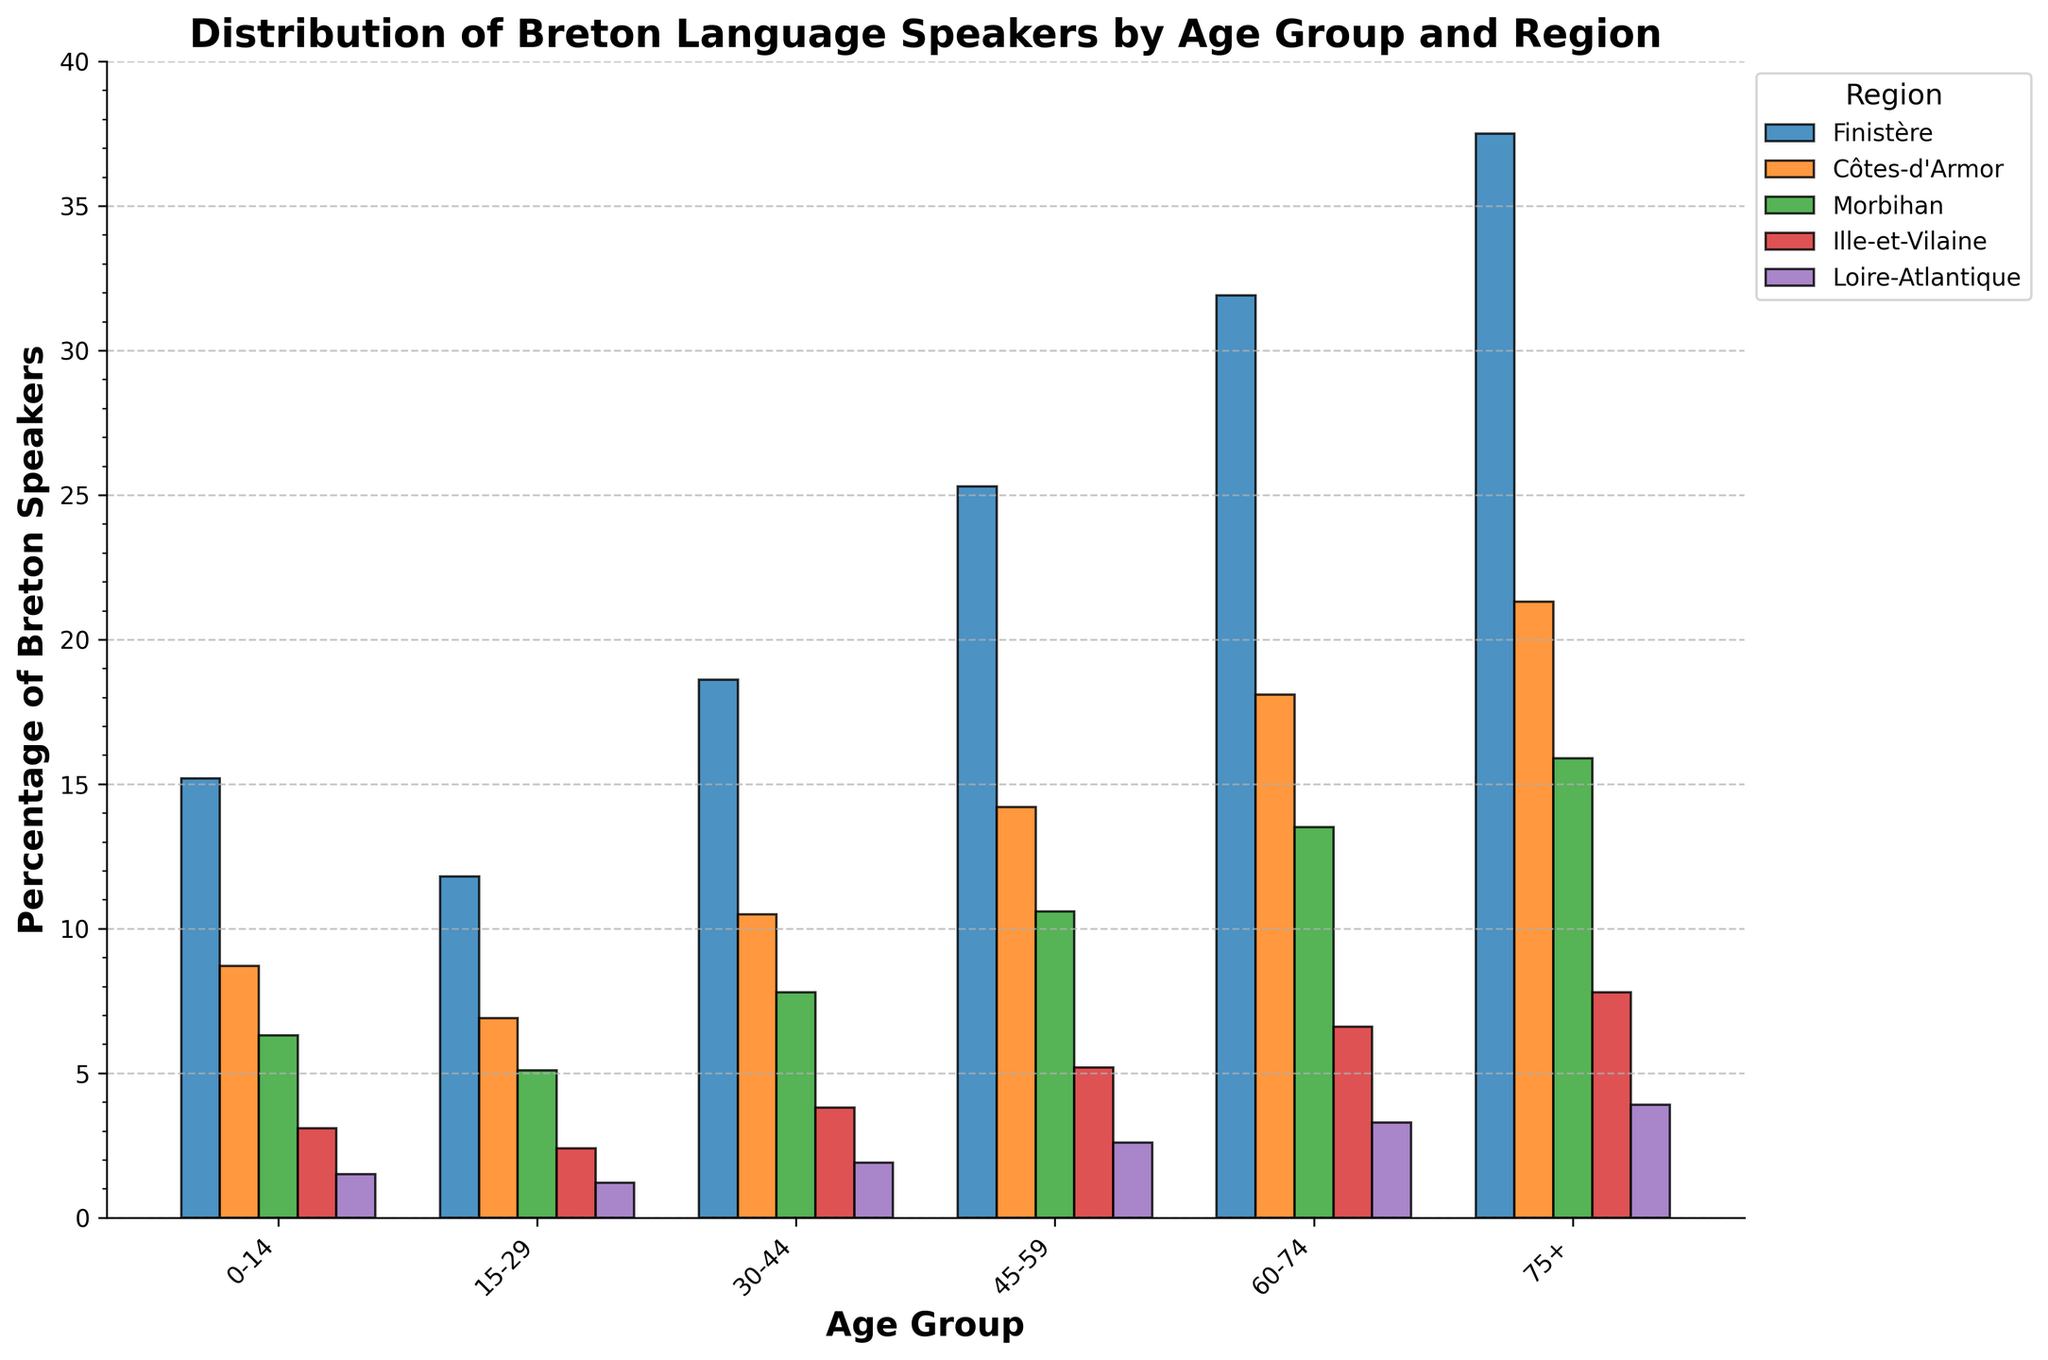What is the percentage of Breton speakers aged 0-14 in Finistère? Look at the bar corresponding to the 0-14 age group for Finistère and read the percentage value.
Answer: 15.2 Which region has the lowest percentage of Breton speakers aged 45-59? Compare the height of the bars for the 45-59 age group across all regions and identify the smallest one.
Answer: Loire-Atlantique Is the percentage of Breton speakers aged 60-74 in Côtes-d'Armor greater than those aged 30-44 in the same region? Compare the height of the bars for the 60-74 and 30-44 age groups in Côtes-d'Armor. The bar for aged 60-74 (18.1) is higher than aged 30-44 (10.5).
Answer: Yes What is the total percentage of Breton speakers aged 75+ across all regions? Sum the percentages for the age group 75+ in all regions: 37.5 (Finistère) + 21.3 (Côtes-d'Armor) + 15.9 (Morbihan) + 7.8 (Ille-et-Vilaine) + 3.9 (Loire-Atlantique).
Answer: 86.4 Which age group in Finistère has the highest percentage of Breton speakers? Look at all the bars representing different age groups in Finistère and identify the tallest one.
Answer: 75+ For the age group 30-44, what is the difference in percentage of Breton speakers between Finistère and Morbihan? Subtract the percentage value of Morbihan from Finistère for age group 30-44: 18.6 (Finistère) - 7.8 (Morbihan).
Answer: 10.8 What is the average percentage of Breton speakers aged 15-29 in Côtes-d'Armor and Ille-et-Vilaine? Add the percentages of the two regions for the age group 15-29 and then divide by 2: (6.9 + 2.4) / 2.
Answer: 4.65 In which region do we observe the smallest growth in percentage of Breton speakers from age group 0-14 to 75+? Calculate the difference between the percentage values of the age groups 75+ and 0-14 for each region; the region with the smallest difference indicates the smallest growth. For Loire-Atlantique: 3.9 - 1.5 = 2.4; for Ille-et-Vilaine: 7.8 - 3.1 = 4.7; for Finistère: 37.5 - 15.2 = 22.3; for Côtes-d'Armor: 21.3 - 8.7 = 12.6; for Morbihan: 15.9 - 6.3 = 9.6.
Answer: Loire-Atlantique 